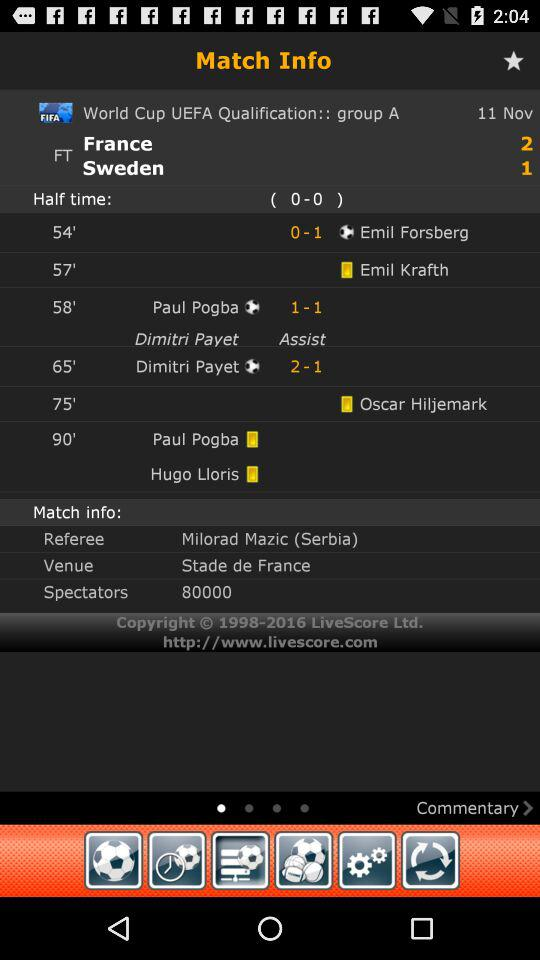What is the venue? The venue is the Stade de France. 